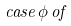<formula> <loc_0><loc_0><loc_500><loc_500>c a s e \, \phi \, o f</formula> 